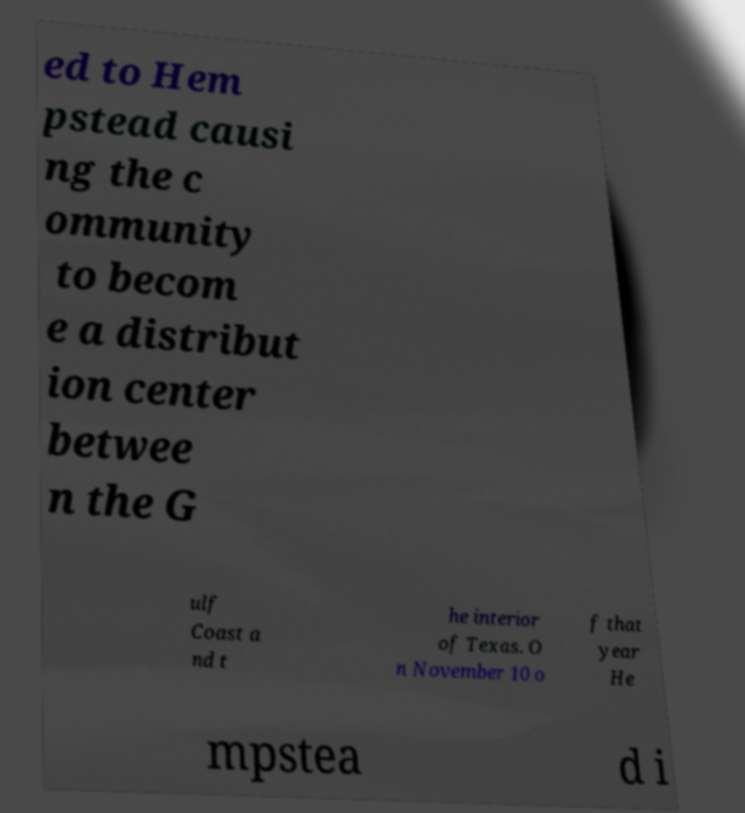Please identify and transcribe the text found in this image. ed to Hem pstead causi ng the c ommunity to becom e a distribut ion center betwee n the G ulf Coast a nd t he interior of Texas. O n November 10 o f that year He mpstea d i 